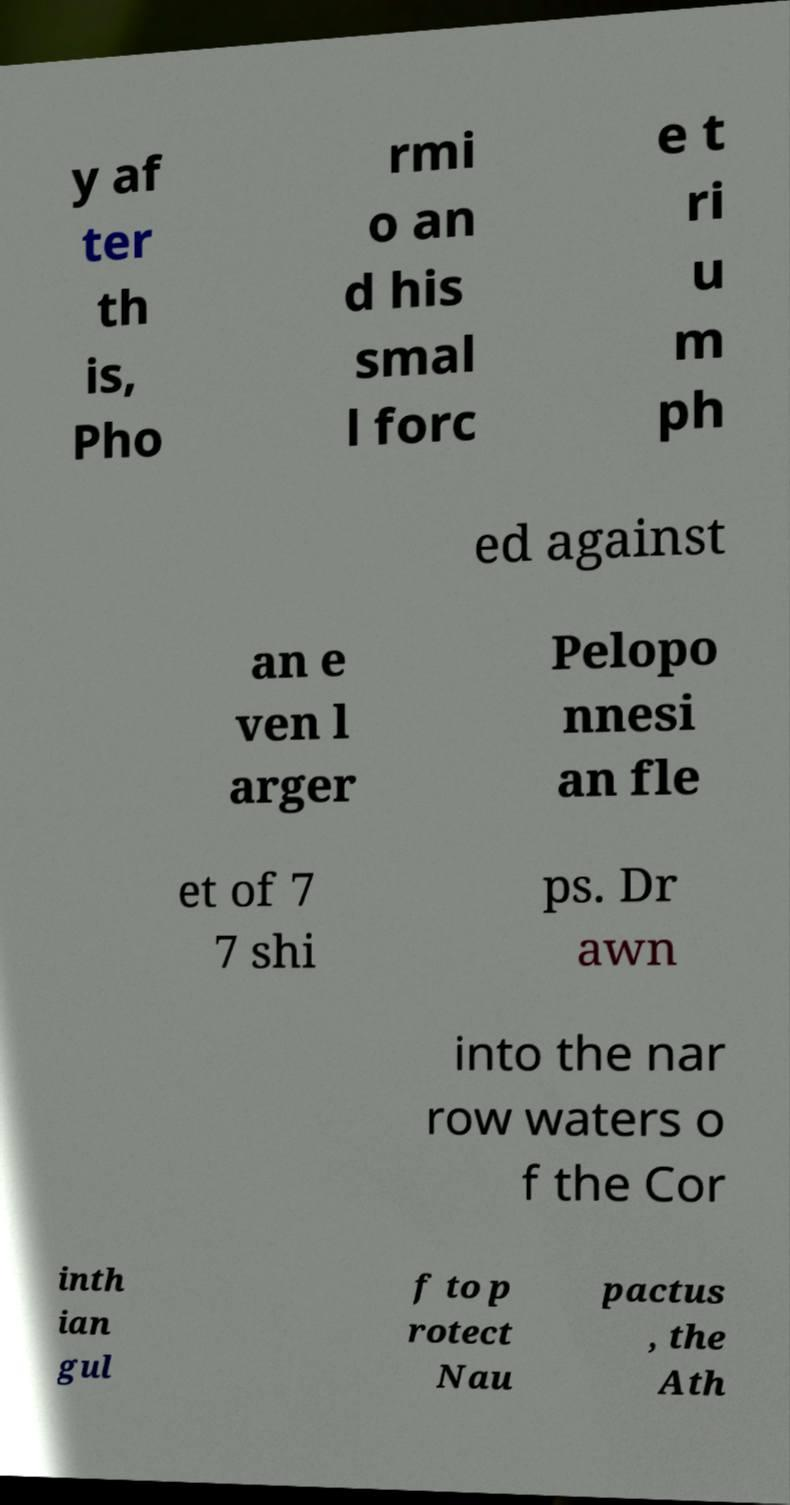What messages or text are displayed in this image? I need them in a readable, typed format. y af ter th is, Pho rmi o an d his smal l forc e t ri u m ph ed against an e ven l arger Pelopo nnesi an fle et of 7 7 shi ps. Dr awn into the nar row waters o f the Cor inth ian gul f to p rotect Nau pactus , the Ath 